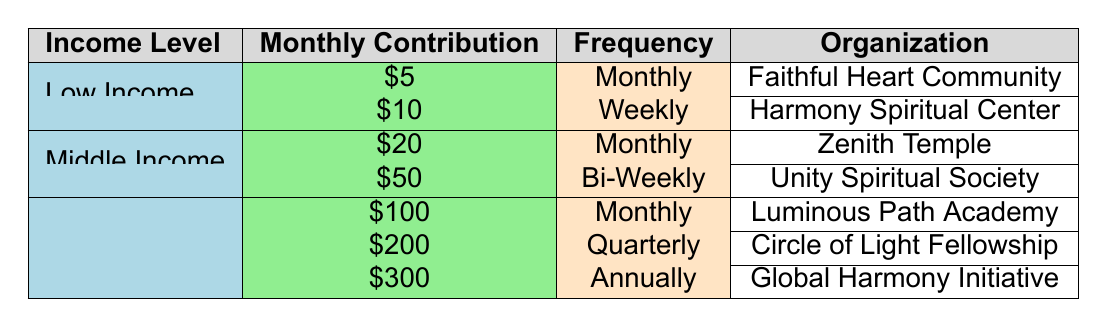What is the highest monthly contribution from any income level? The highest monthly contribution in the table is from the High Income level at $300, which is listed under the Global Harmony Initiative organization with an annual contribution frequency.
Answer: 300 Which spiritual organization receives contributions from low-income individuals? The Faithful Heart Community receives $5 monthly contributions from low-income individuals, and the Harmony Spiritual Center receives $10 weekly contributions from them.
Answer: Faithful Heart Community, Harmony Spiritual Center How many organizations accept monthly contributions? From the table, there are three organizations that accept monthly contributions: Faithful Heart Community ($5), Zenith Temple ($20), and Luminous Path Academy ($100).
Answer: 3 Is there any organization that receives contributions more frequently than monthly from low-income donors? No, there are only monthly and weekly contributions listed for low-income donors. The Harmony Spiritual Center is the only one that receives weekly contributions.
Answer: No What is the total monthly contribution received from middle-income organizations? The total monthly contributions for middle-income organizations are $20 from Zenith Temple and $50 from Unity Spiritual Society. Summing these gives $20 + $50 = $70.
Answer: 70 How many organizations have a frequency of contribution listed as quarterly? Only one organization, the Circle of Light Fellowship, has a quarterly frequency of contribution, which is from a high-income individual contributing $200.
Answer: 1 Which income level contributes the lowest amount, and how much is it? Low Income contributes the lowest amount at $5 through the Faithful Heart Community, as it's the smallest contribution listed in the table.
Answer: Low Income, 5 What is the average contribution amount for high-income donors? To calculate the average contribution for high-income donors, we take the contributions of $100, $200, and $300. The sum is $100 + $200 + $300 = $600, and there are three contributors. The average is $600 / 3 = $200.
Answer: 200 Are there any organizations that accept bi-weekly contributions from low-income donors? No, the table does not list any organizations for low-income donors that accept bi-weekly contributions; all low-income contributions are weekly or monthly.
Answer: No 